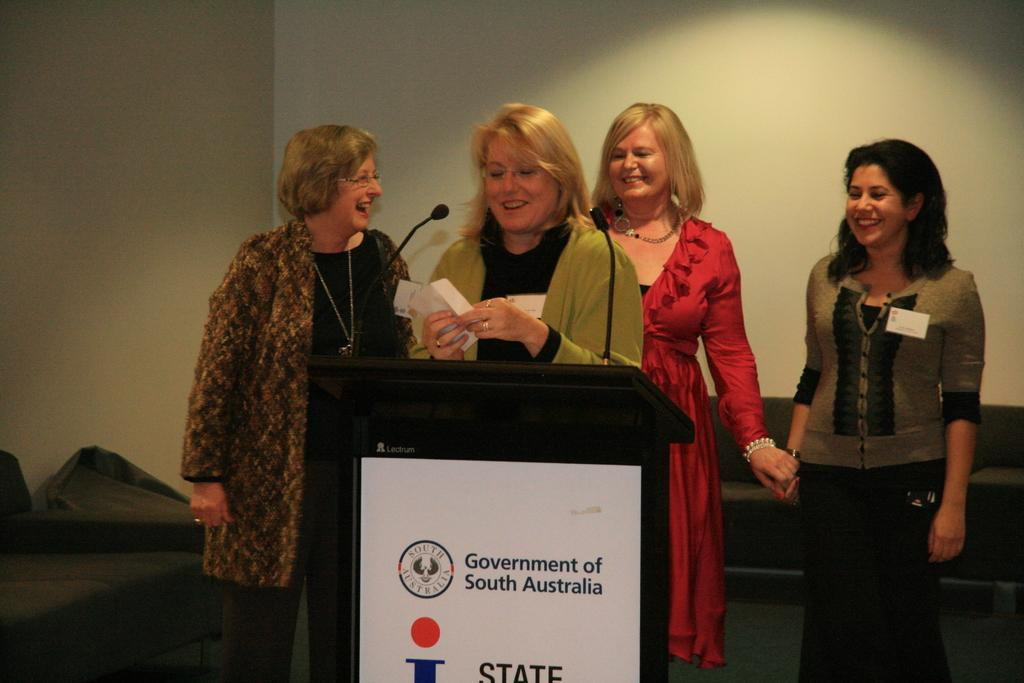How many women are in the image? There are four women standing and smiling in the image. What can be seen near the women? There is a podium with a microphone and a board attached to it. What type of furniture is present in the image? There are couches in the image. What is visible in the background of the image? There is a wall visible in the image. Can you tell me how many grapes are on the island in the image? There is no island or grapes present in the image. What sense is being used by the women in the image? The provided facts do not mention any specific sense being used by the women in the image. 